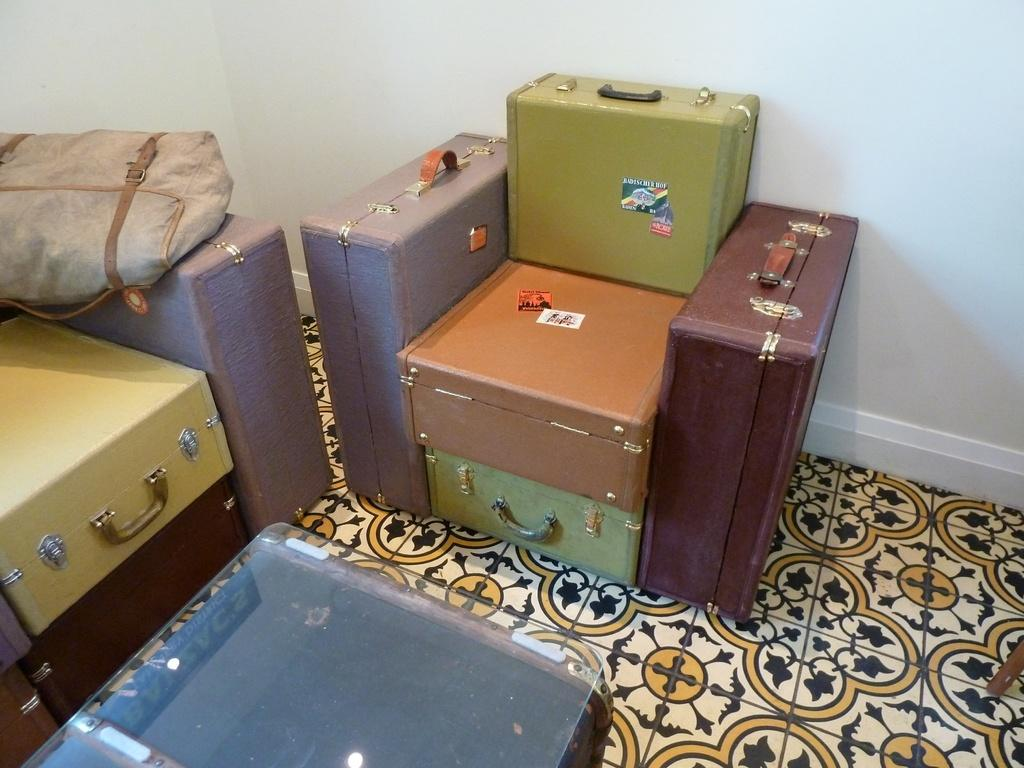What type of object is present in the image that people might use for carrying belongings? There is baggage in the image that people might use for carrying belongings. What type of object is present in the image that people might use for drinking? There is a glass in the image that people might use for drinking. What type of produce can be seen growing on the trees in the image? There are no trees or produce present in the image; it only contains baggage and a glass. 